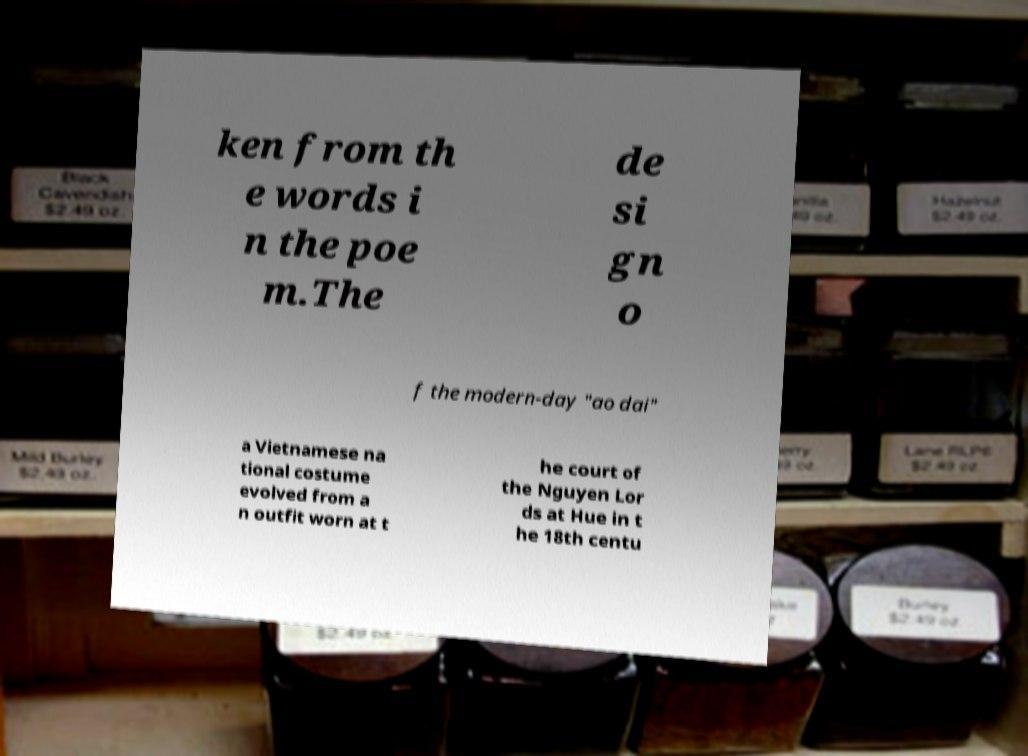Can you accurately transcribe the text from the provided image for me? ken from th e words i n the poe m.The de si gn o f the modern-day "ao dai" a Vietnamese na tional costume evolved from a n outfit worn at t he court of the Nguyen Lor ds at Hue in t he 18th centu 